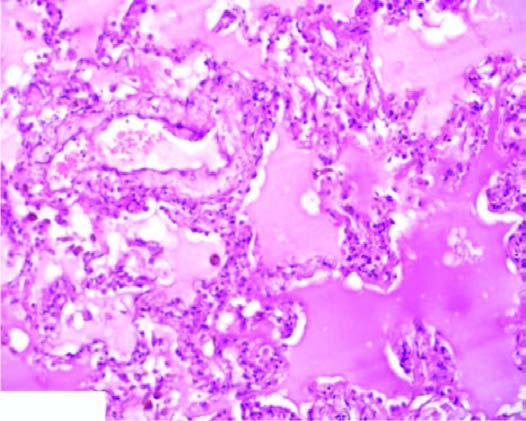re many of the hepatocytes congested?
Answer the question using a single word or phrase. No 